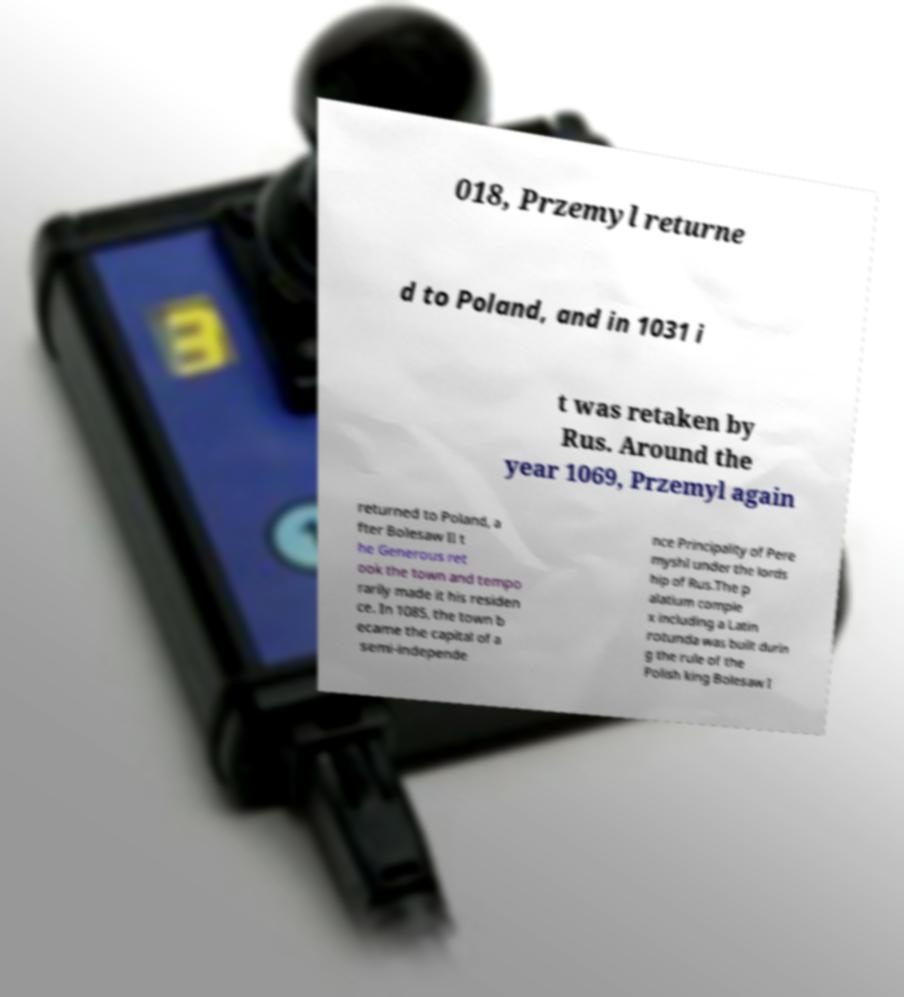Please identify and transcribe the text found in this image. 018, Przemyl returne d to Poland, and in 1031 i t was retaken by Rus. Around the year 1069, Przemyl again returned to Poland, a fter Bolesaw II t he Generous ret ook the town and tempo rarily made it his residen ce. In 1085, the town b ecame the capital of a semi-independe nce Principality of Pere myshl under the lords hip of Rus.The p alatium comple x including a Latin rotunda was built durin g the rule of the Polish king Bolesaw I 